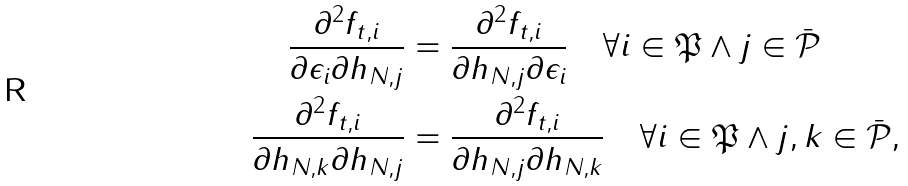Convert formula to latex. <formula><loc_0><loc_0><loc_500><loc_500>\frac { \partial ^ { 2 } f _ { t , i } } { \partial \epsilon _ { i } \partial h _ { N , j } } & = \frac { \partial ^ { 2 } f _ { t , i } } { \partial h _ { N , j } \partial \epsilon _ { i } } \quad \forall i \in \mathfrak { P } \land j \in \bar { \mathcal { P } } \\ \frac { \partial ^ { 2 } f _ { t , i } } { \partial h _ { N , k } \partial h _ { N , j } } & = \frac { \partial ^ { 2 } f _ { t , i } } { \partial h _ { N , j } \partial h _ { N , k } } \quad \forall i \in \mathfrak { P } \land j , k \in \bar { \mathcal { P } } ,</formula> 